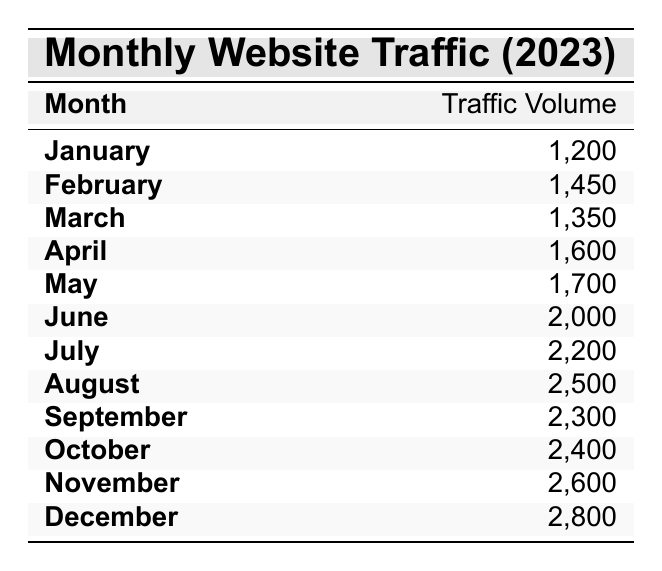What was the highest traffic volume recorded in a month? By scanning the table, the month with the highest traffic volume can be identified as December, which has a traffic volume of 2800.
Answer: 2800 What traffic volume did March see? The table shows that March had a traffic volume of 1350.
Answer: 1350 Did website traffic peak in July? By reviewing the table, it is clear that traffic in July (2200) is not the peak; December (2800) has the highest traffic volume.
Answer: No What is the average monthly website traffic volume over the year? I need to sum the traffic volumes of all months: 1200 + 1450 + 1350 + 1600 + 1700 + 2000 + 2200 + 2500 + 2300 + 2400 + 2600 + 2800 = 22600. There are 12 months, so the average is 22600 / 12 = 1883.33.
Answer: 1883.33 How many months had traffic volumes over 2000? By examining the table, I count the months above 2000: June (2000), July (2200), August (2500), September (2300), October (2400), November (2600), December (2800), which gives us 7 months.
Answer: 7 What is the difference in traffic volume between the busiest month and the slowest month? The busiest month is December with 2800 and the slowest month is January with 1200. I calculate the difference: 2800 - 1200 = 1600.
Answer: 1600 Which month had a traffic volume of 1500 or less? Looking through the table, the only month with a traffic volume of 1500 or less is January, which had 1200.
Answer: January Was there a month with a traffic volume exactly equal to 2000? The table shows that June had a traffic volume of 2000, confirming that there was indeed a month meeting that criterion.
Answer: Yes What is the median traffic volume for the months in the table? To find the median, I first list the traffic volumes in order: 1200, 1350, 1450, 1600, 1700, 2000, 2200, 2300, 2400, 2600, 2800. Since we have 12 months (an even number), the median will be the average of the 6th (2000) and 7th (2200) values: (2000 + 2200) / 2 = 2100.
Answer: 2100 